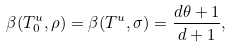Convert formula to latex. <formula><loc_0><loc_0><loc_500><loc_500>\beta ( T _ { 0 } ^ { u } , \rho ) = \beta ( T ^ { u } , \sigma ) = \frac { d \theta + 1 } { d + 1 } ,</formula> 